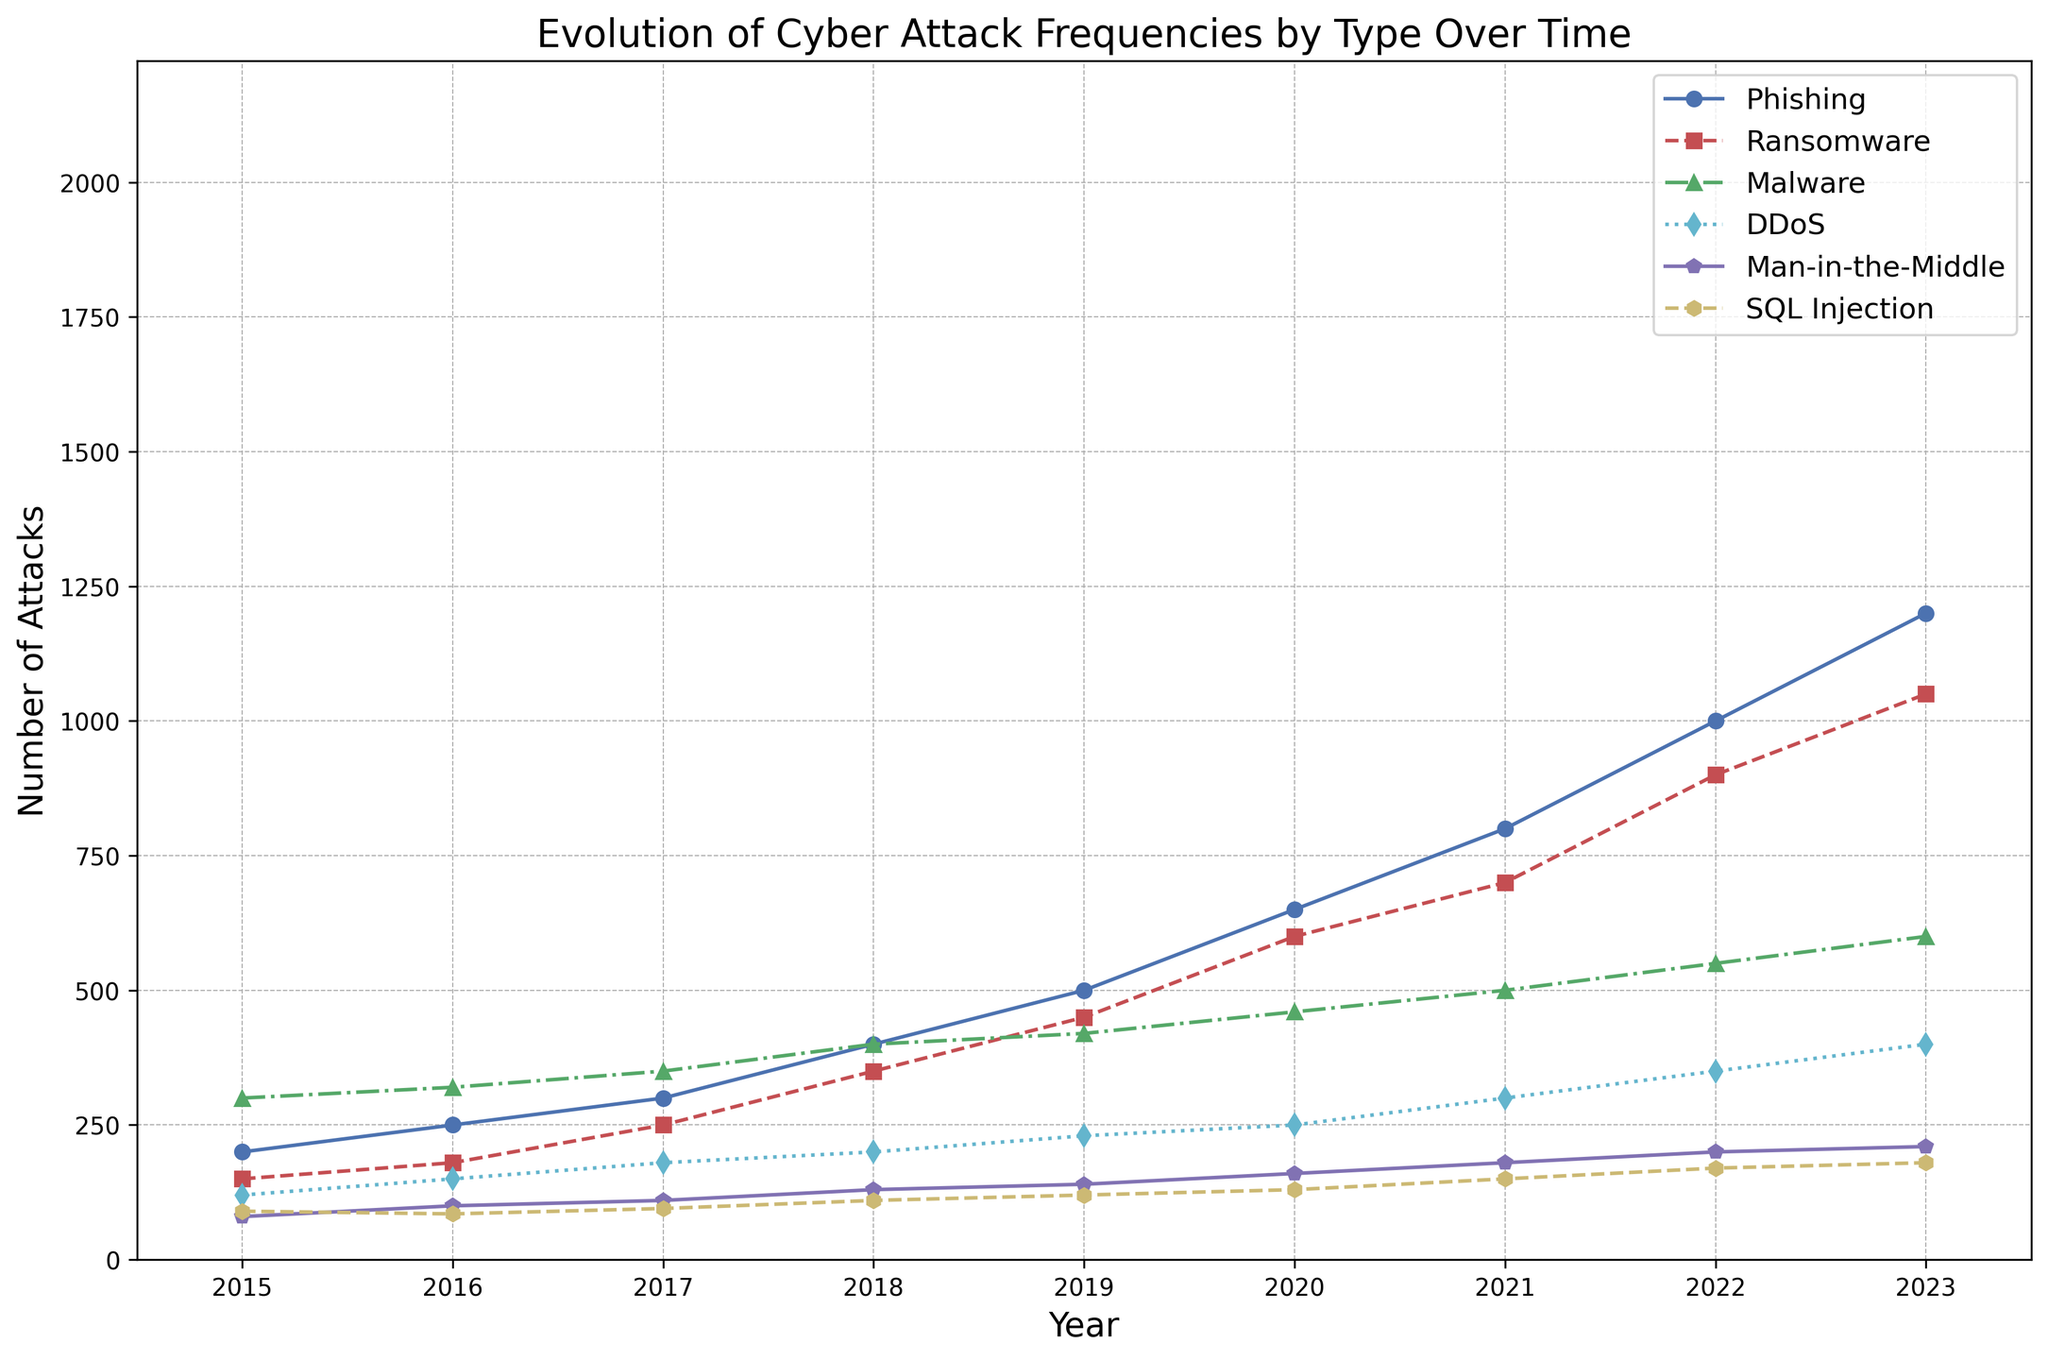What year did Phishing attacks surpass 1000 incidents? To find out when Phishing attacks surpassed 1000 incidents, check the line labeled "Phishing" and identify the corresponding year when the data point exceeds 1000. According to the figure, this occurred in 2022.
Answer: 2022 Which type of attack had the greatest increase in frequency between 2015 and 2023? Calculate the difference in the number of attacks for each type between 2015 and 2023. For Phishing: 1200 - 200 = 1000, Ransomware: 1050 - 150 = 900, Malware: 600 - 300 = 300, DDoS: 400 - 120 = 280, Man-in-the-Middle: 210 - 80 = 130, SQL Injection: 180 - 90 = 90. Phishing had the greatest increase.
Answer: Phishing In which year were DDoS attacks first recorded at 200 or more incidents? Examine the DDoS line and track the data points year by year until you reach the first point where the frequency is at least 200. This occurs in 2018.
Answer: 2018 What was the frequency of Ransomware attacks in 2017, and how does it compare to 2020? Look at the Ransomware line and identify the data points for 2017 and 2020. In 2017, it was 250, and in 2020, it increased to 600. So, 600 - 250 = 350 more in 2020.
Answer: 250 in 2017, 350 more in 2020 By how much did the number of Malware attacks increase from 2015 to 2023? Identify the Malware incidents in both years. For 2015, it’s 300, and for 2023, it’s 600. Subtract 300 from 600 to find the increase, which is 600 - 300 = 300.
Answer: 300 Are there any attack types with frequencies that either stagnate or decrease at any point over the given years? Observe the trends for all types of attacks. Each shows a general increase with no noticeable stagnation or decrease over the years.
Answer: No Which attacks have an increasing trend but show the slowest growth rate between 2015 and 2023? Compare the slopes of the lines for all attack types. SQL Injection had the least growth, increasing by 90 incidents over this period (180 in 2023 - 90 in 2015).
Answer: SQL Injection Which year saw the sharpest increase in Ransomware attacks and by how much? Find the year-over-year differences for Ransomware. 2021 to 2022 has the sharpest increase, calculated as 900 - 700 = 200.
Answer: 2021 to 2022, by 200 How did Man-in-the-Middle attacks change from 2016 to 2021? Check the data for Man-in-the-Middle attacks in 2016 and 2021. The incidents in 2016 were 100 and in 2021 were 180. The increase is 180 - 100 = 80.
Answer: Increased by 80 Between which years did Phishing attacks increase by 50 incidents? Identify consecutive years on the Phishing line where the difference is 50. Between 2015 (200) and 2016 (250), the increase is 50.
Answer: 2015 to 2016 